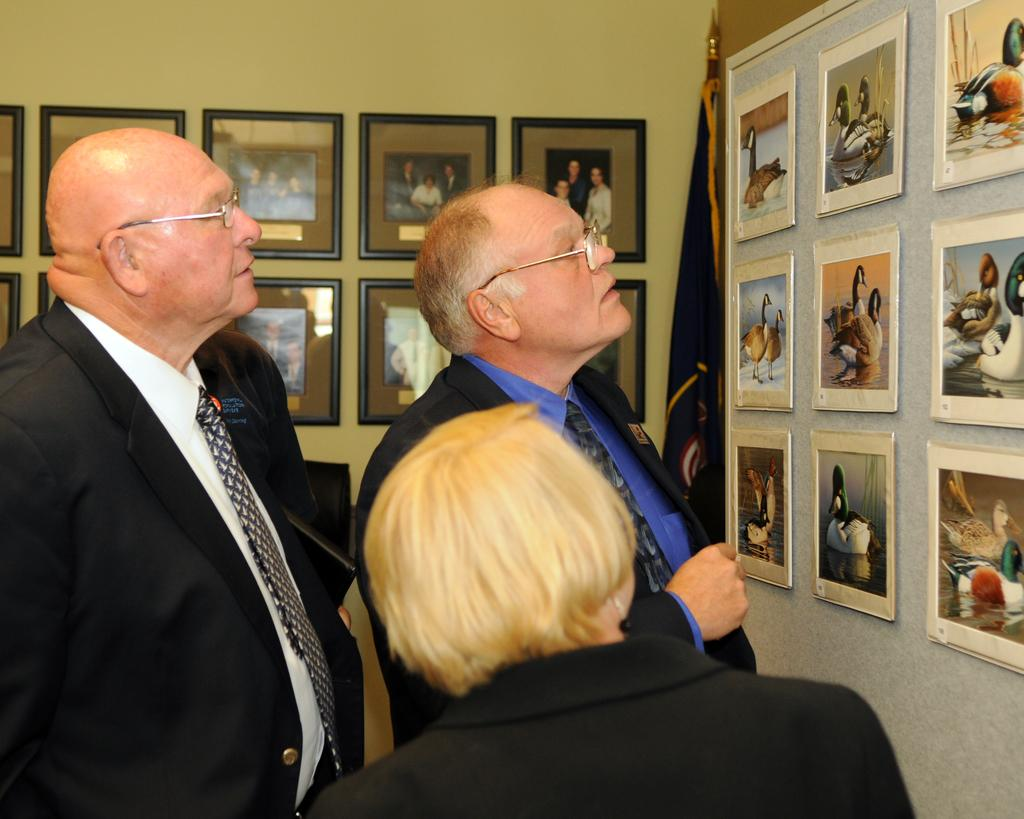How many people are in the image? There is a group of people in the image. Can you describe any specific features of the people in the group? Some people in the group are wearing spectacles. What is located in front of the group? There is a flag in front of the group. What can be seen on the walls in the image? There are frames on the walls in the image. What type of pen is being used by the person in the image? There is no pen visible in the image. Can you describe the locket worn by the person in the image? There is no locket visible in the image. 